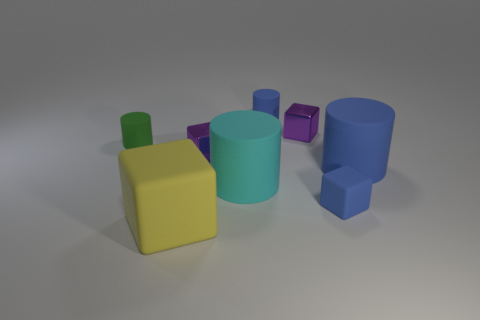Can you describe the largest object in the image? The largest object in the image is a light blue matte cylinder. It has a broad base and its height appears to be the tallest among all objects present. 